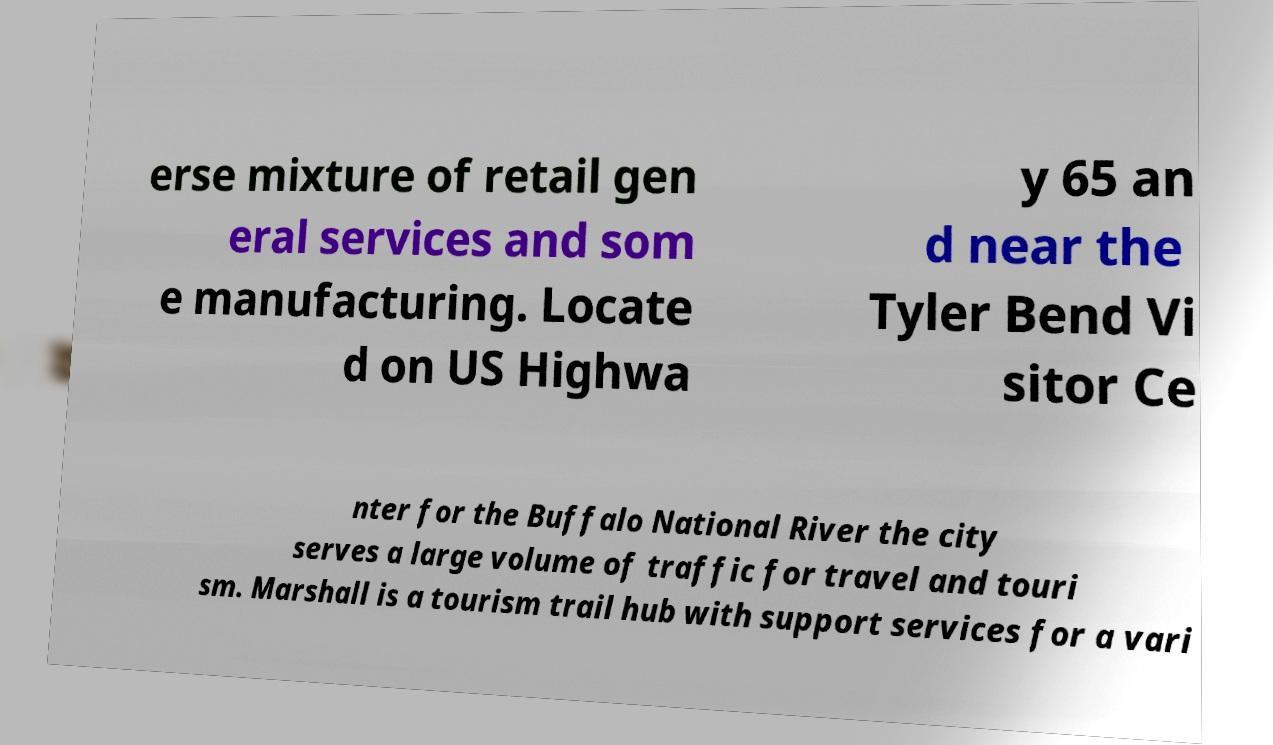Could you assist in decoding the text presented in this image and type it out clearly? erse mixture of retail gen eral services and som e manufacturing. Locate d on US Highwa y 65 an d near the Tyler Bend Vi sitor Ce nter for the Buffalo National River the city serves a large volume of traffic for travel and touri sm. Marshall is a tourism trail hub with support services for a vari 